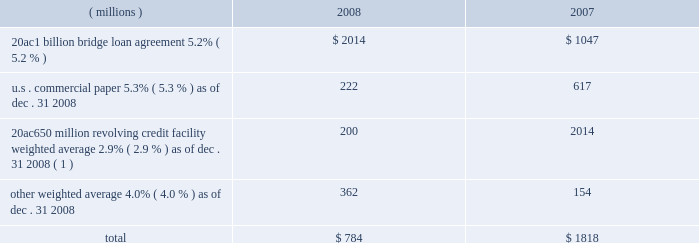Notes to the consolidated financial statements on march 18 , 2008 , ppg completed a public offering of $ 600 million in aggregate principal amount of its 5.75% ( 5.75 % ) notes due 2013 ( the 201c2013 notes 201d ) , $ 700 million in aggregate principal amount of its 6.65% ( 6.65 % ) notes due 2018 ( the 201c2018 notes 201d ) and $ 250 million in aggregate principal amount of its 7.70% ( 7.70 % ) notes due 2038 ( the 201c2038 notes 201d and , together with the 2013 notes and the 2018 notes , the 201cnotes 201d ) .
The notes were offered by the company pursuant to its existing shelf registration .
The proceeds of this offering of $ 1538 million ( net of discount and issuance costs ) and additional borrowings of $ 195 million under the 20ac650 million revolving credit facility were used to repay existing debt , including certain short-term debt and the amounts outstanding under the 20ac1 billion bridge loan .
No further amounts can be borrowed under the 20ac1 billion bridge loan .
The discount and issuance costs related to the notes , which totaled $ 12 million , will be amortized to interest expense over the respective lives of the notes .
Short-term debt outstanding as of december 31 , 2008 and 2007 , was as follows : ( millions ) 2008 2007 .
Total $ 784 $ 1818 ( 1 ) borrowings under this facility have a term of 30 days and can be rolled over monthly until the facility expires in 2010 .
Ppg is in compliance with the restrictive covenants under its various credit agreements , loan agreements and indentures .
The company 2019s revolving credit agreements include a financial ratio covenant .
The covenant requires that the amount of total indebtedness not exceed 60% ( 60 % ) of the company 2019s total capitalization excluding the portion of accumulated other comprehensive income ( loss ) related to pensions and other postretirement benefit adjustments .
As of december 31 , 2008 , total indebtedness was 45% ( 45 % ) of the company 2019s total capitalization excluding the portion of accumulated other comprehensive income ( loss ) related to pensions and other postretirement benefit adjustments .
Additionally , substantially all of the company 2019s debt agreements contain customary cross- default provisions .
Those provisions generally provide that a default on a debt service payment of $ 10 million or more for longer than the grace period provided ( usually 10 days ) under one agreement may result in an event of default under other agreements .
None of the company 2019s primary debt obligations are secured or guaranteed by the company 2019s affiliates .
Interest payments in 2008 , 2007 and 2006 totaled $ 228 million , $ 102 million and $ 90 million , respectively .
Rental expense for operating leases was $ 267 million , $ 188 million and $ 161 million in 2008 , 2007 and 2006 , respectively .
The primary leased assets include paint stores , transportation equipment , warehouses and other distribution facilities , and office space , including the company 2019s corporate headquarters located in pittsburgh , pa .
Minimum lease commitments for operating leases that have initial or remaining lease terms in excess of one year as of december 31 , 2008 , are ( in millions ) $ 126 in 2009 , $ 107 in 2010 , $ 82 in 2011 , $ 65 in 2012 , $ 51 in 2013 and $ 202 thereafter .
The company had outstanding letters of credit of $ 82 million as of december 31 , 2008 .
The letters of credit secure the company 2019s performance to third parties under certain self-insurance programs and other commitments made in the ordinary course of business .
As of december 31 , 2008 and 2007 guarantees outstanding were $ 70 million .
The guarantees relate primarily to debt of certain entities in which ppg has an ownership interest and selected customers of certain of the company 2019s businesses .
A portion of such debt is secured by the assets of the related entities .
The carrying values of these guarantees were $ 9 million and $ 3 million as of december 31 , 2008 and 2007 , respectively , and the fair values were $ 40 million and $ 17 million , as of december 31 , 2008 and 2007 , respectively .
The company does not believe any loss related to these letters of credit or guarantees is likely .
10 .
Financial instruments , excluding derivative financial instruments included in ppg 2019s financial instrument portfolio are cash and cash equivalents , cash held in escrow , marketable equity securities , company-owned life insurance and short- and long-term debt instruments .
The fair values of the financial instruments approximated their carrying values , in the aggregate , except for long-term long-term debt ( excluding capital lease obligations ) , had carrying and fair values totaling $ 3122 million and $ 3035 million , respectively , as of december 31 , 2008 .
The corresponding amounts as of december 31 , 2007 , were $ 1201 million and $ 1226 million , respectively .
The fair values of the debt instruments were based on discounted cash flows and interest rates currently available to the company for instruments of the same remaining maturities .
2008 ppg annual report and form 10-k 45 .
What was the percentage change in interest payments from 2007 to 2008? 
Computations: ((228 - 102) / 102)
Answer: 1.23529. 